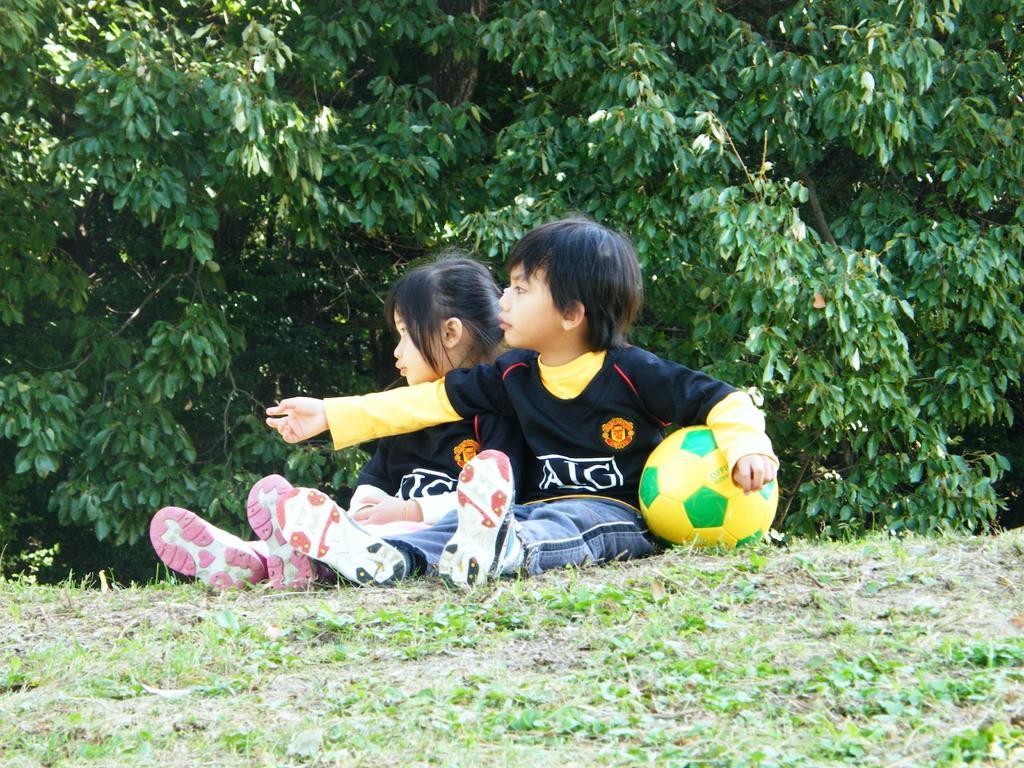Describe this image in one or two sentences. In this image we can see two children wearing black T-shirts are sitting on the ground and this child is holding a yellow ball in his hands. In the background, we can see the trees. 